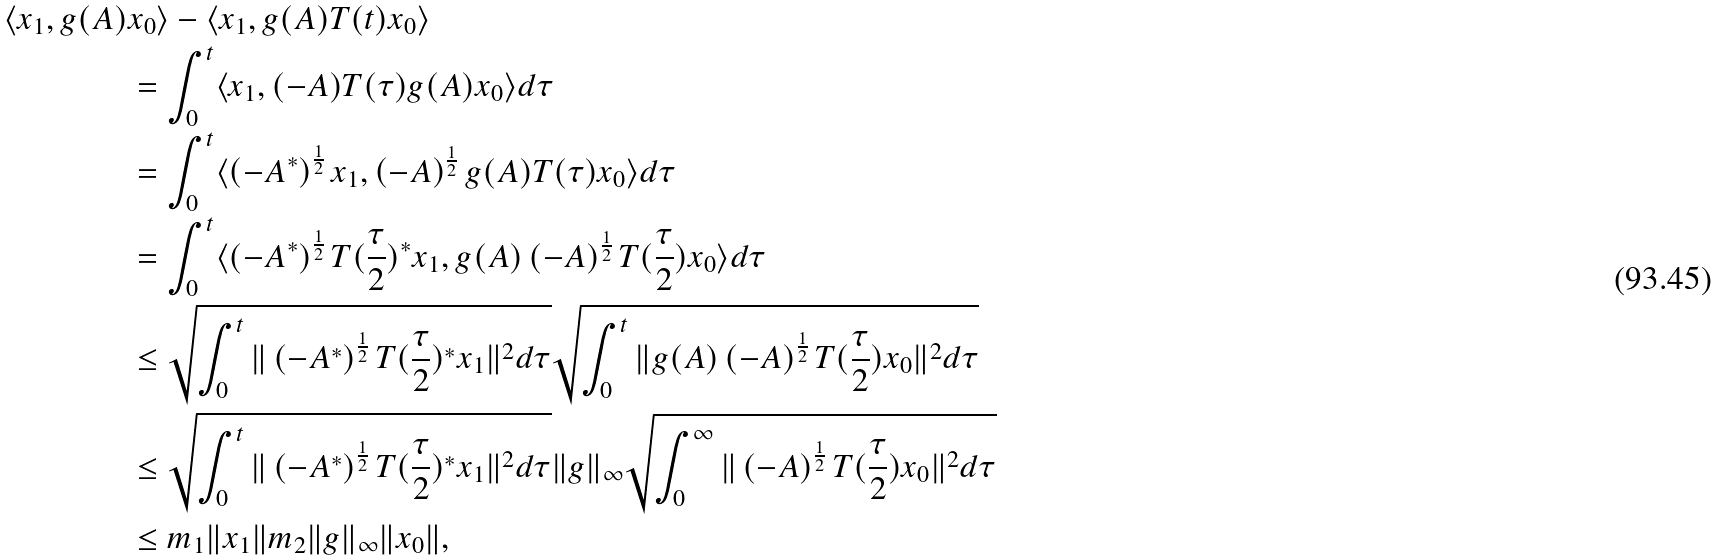<formula> <loc_0><loc_0><loc_500><loc_500>\langle x _ { 1 } , g ( A ) & x _ { 0 } \rangle - \langle x _ { 1 } , g ( A ) T ( t ) x _ { 0 } \rangle \\ & = \int _ { 0 } ^ { t } \langle x _ { 1 } , ( - A ) T ( \tau ) g ( A ) x _ { 0 } \rangle d \tau \\ & = \int _ { 0 } ^ { t } \langle \left ( - A ^ { * } \right ) ^ { \frac { 1 } { 2 } } x _ { 1 } , \left ( - A \right ) ^ { \frac { 1 } { 2 } } g ( A ) T ( \tau ) x _ { 0 } \rangle d \tau \\ & = \int _ { 0 } ^ { t } \langle \left ( - A ^ { * } \right ) ^ { \frac { 1 } { 2 } } T ( \frac { \tau } { 2 } ) ^ { * } x _ { 1 } , g ( A ) \left ( - A \right ) ^ { \frac { 1 } { 2 } } T ( \frac { \tau } { 2 } ) x _ { 0 } \rangle d \tau \\ & \leq \sqrt { \int _ { 0 } ^ { t } \| \left ( - A ^ { * } \right ) ^ { \frac { 1 } { 2 } } T ( \frac { \tau } { 2 } ) ^ { * } x _ { 1 } \| ^ { 2 } d \tau } \sqrt { \int _ { 0 } ^ { t } \| g ( A ) \left ( - A \right ) ^ { \frac { 1 } { 2 } } T ( \frac { \tau } { 2 } ) x _ { 0 } \| ^ { 2 } d \tau } \\ & \leq \sqrt { \int _ { 0 } ^ { t } \| \left ( - A ^ { * } \right ) ^ { \frac { 1 } { 2 } } T ( \frac { \tau } { 2 } ) ^ { * } x _ { 1 } \| ^ { 2 } d \tau } \| g \| _ { \infty } \sqrt { \int _ { 0 } ^ { \infty } \| \left ( - A \right ) ^ { \frac { 1 } { 2 } } T ( \frac { \tau } { 2 } ) x _ { 0 } \| ^ { 2 } d \tau } \\ & \leq m _ { 1 } \| x _ { 1 } \| m _ { 2 } \| g \| _ { \infty } \| x _ { 0 } \| ,</formula> 